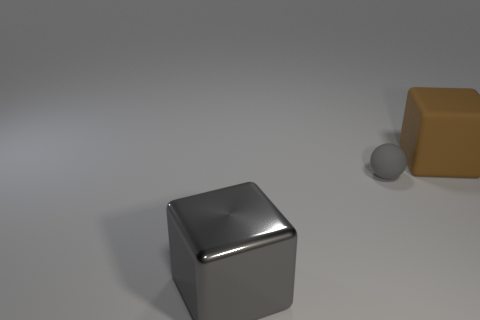Subtract 1 balls. How many balls are left? 0 Subtract all gray blocks. How many blocks are left? 1 Subtract all cubes. How many objects are left? 1 Subtract all green cubes. Subtract all blue cylinders. How many cubes are left? 2 Subtract all purple cylinders. How many gray cubes are left? 1 Subtract all gray rubber balls. Subtract all brown rubber blocks. How many objects are left? 1 Add 1 large gray metallic cubes. How many large gray metallic cubes are left? 2 Add 2 gray metallic things. How many gray metallic things exist? 3 Add 2 large red rubber cylinders. How many objects exist? 5 Subtract 0 yellow spheres. How many objects are left? 3 